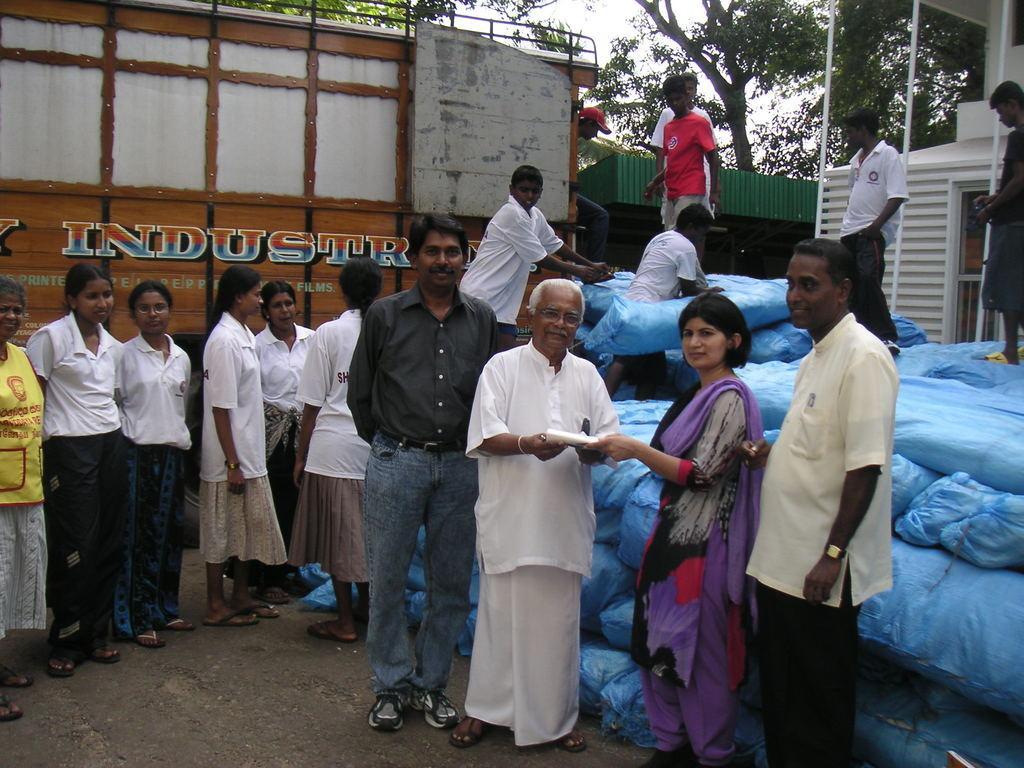Could you give a brief overview of what you see in this image? In front of the image there is an old man and a woman holding some object in their hands, around them there are a few other people, behind them there is a truck and there are some objects placed in bags. In the background of the image there is a building and trees, 